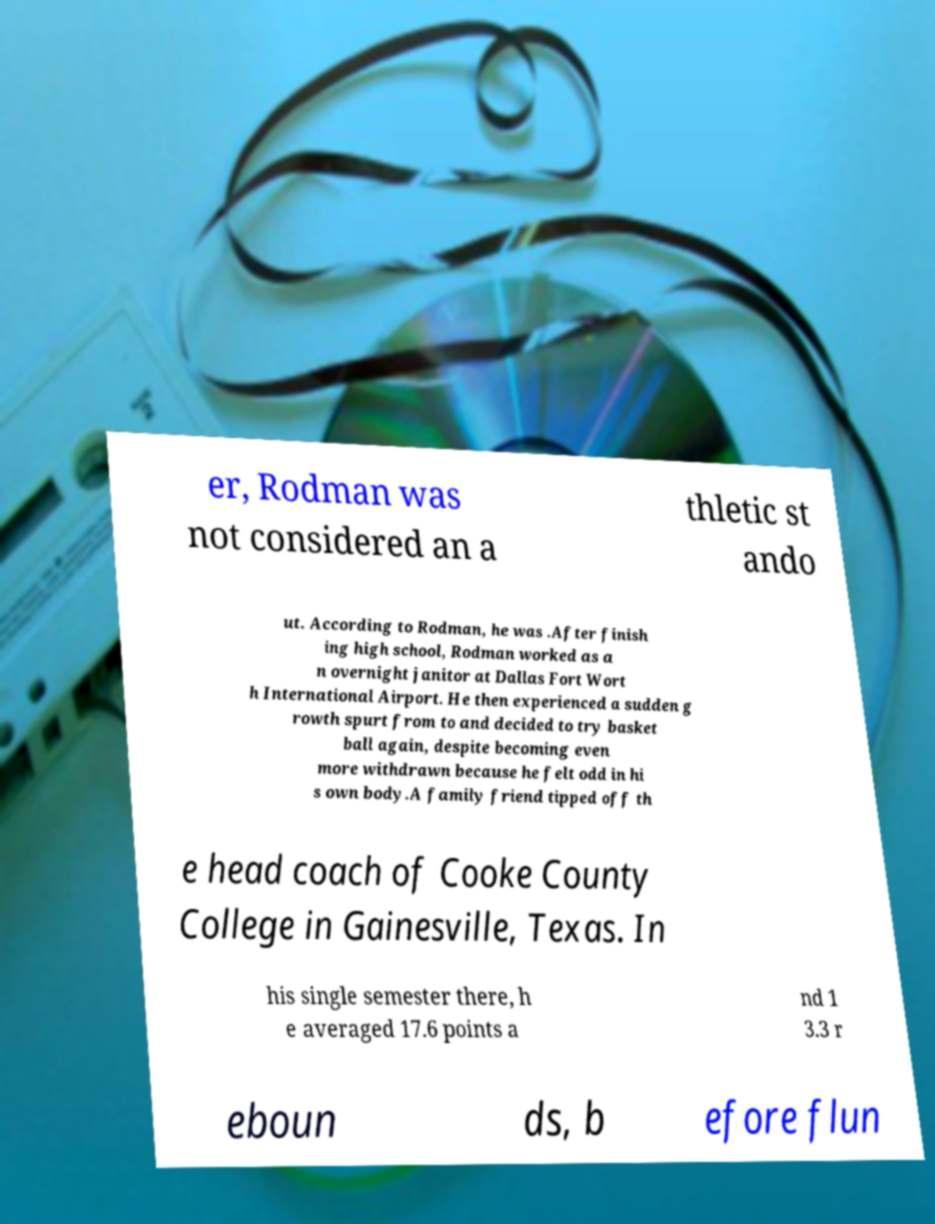Could you assist in decoding the text presented in this image and type it out clearly? er, Rodman was not considered an a thletic st ando ut. According to Rodman, he was .After finish ing high school, Rodman worked as a n overnight janitor at Dallas Fort Wort h International Airport. He then experienced a sudden g rowth spurt from to and decided to try basket ball again, despite becoming even more withdrawn because he felt odd in hi s own body.A family friend tipped off th e head coach of Cooke County College in Gainesville, Texas. In his single semester there, h e averaged 17.6 points a nd 1 3.3 r eboun ds, b efore flun 